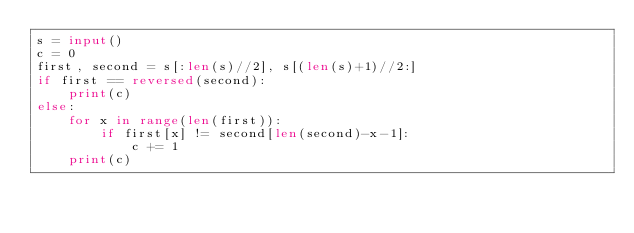<code> <loc_0><loc_0><loc_500><loc_500><_Python_>s = input()
c = 0
first, second = s[:len(s)//2], s[(len(s)+1)//2:]
if first == reversed(second):
    print(c)
else:
    for x in range(len(first)):
        if first[x] != second[len(second)-x-1]:
            c += 1
    print(c)</code> 